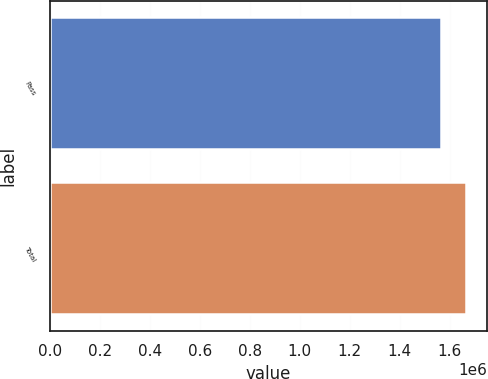Convert chart. <chart><loc_0><loc_0><loc_500><loc_500><bar_chart><fcel>Pass<fcel>Total<nl><fcel>1.56426e+06<fcel>1.66691e+06<nl></chart> 